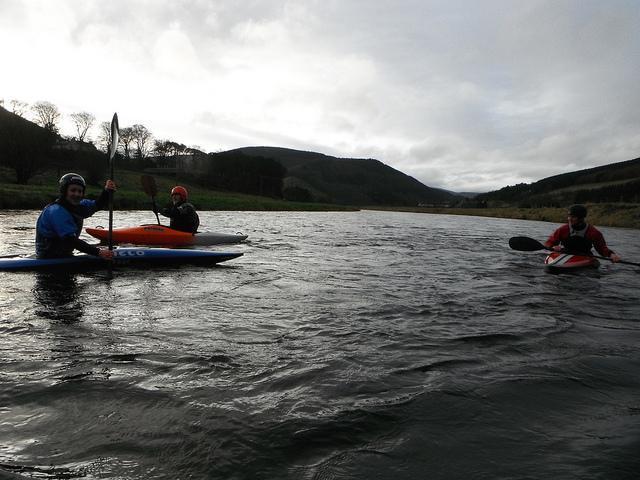How many people are wearing hats?
Give a very brief answer. 3. How many people are in the image?
Give a very brief answer. 3. How many boats are there?
Give a very brief answer. 2. How many pieces of broccoli are there in the dinner?
Give a very brief answer. 0. 